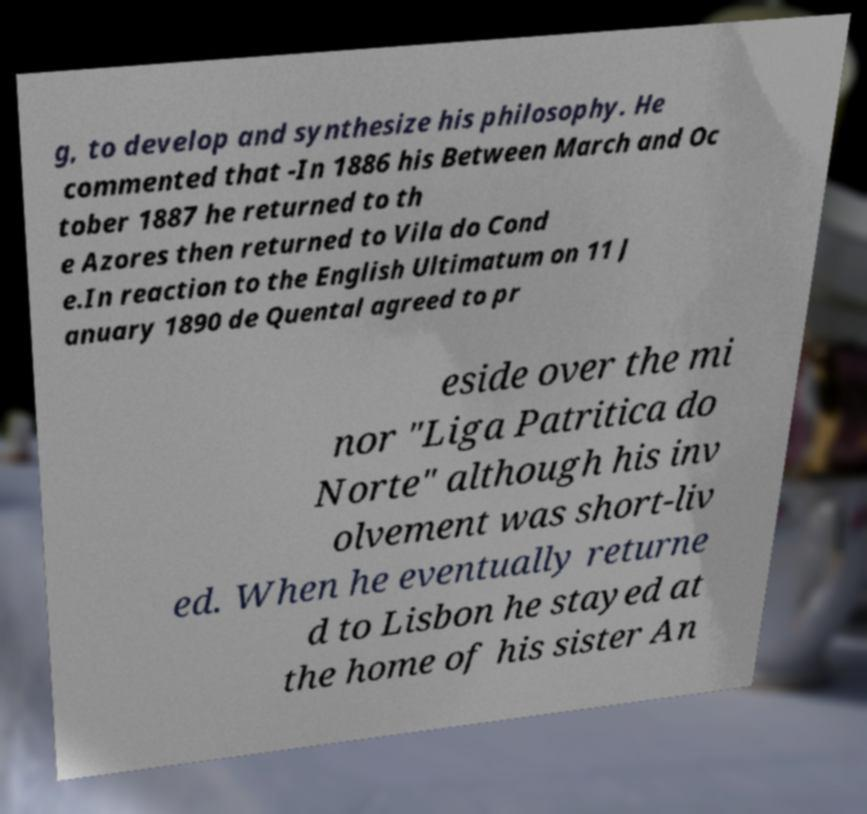There's text embedded in this image that I need extracted. Can you transcribe it verbatim? g, to develop and synthesize his philosophy. He commented that -In 1886 his Between March and Oc tober 1887 he returned to th e Azores then returned to Vila do Cond e.In reaction to the English Ultimatum on 11 J anuary 1890 de Quental agreed to pr eside over the mi nor "Liga Patritica do Norte" although his inv olvement was short-liv ed. When he eventually returne d to Lisbon he stayed at the home of his sister An 